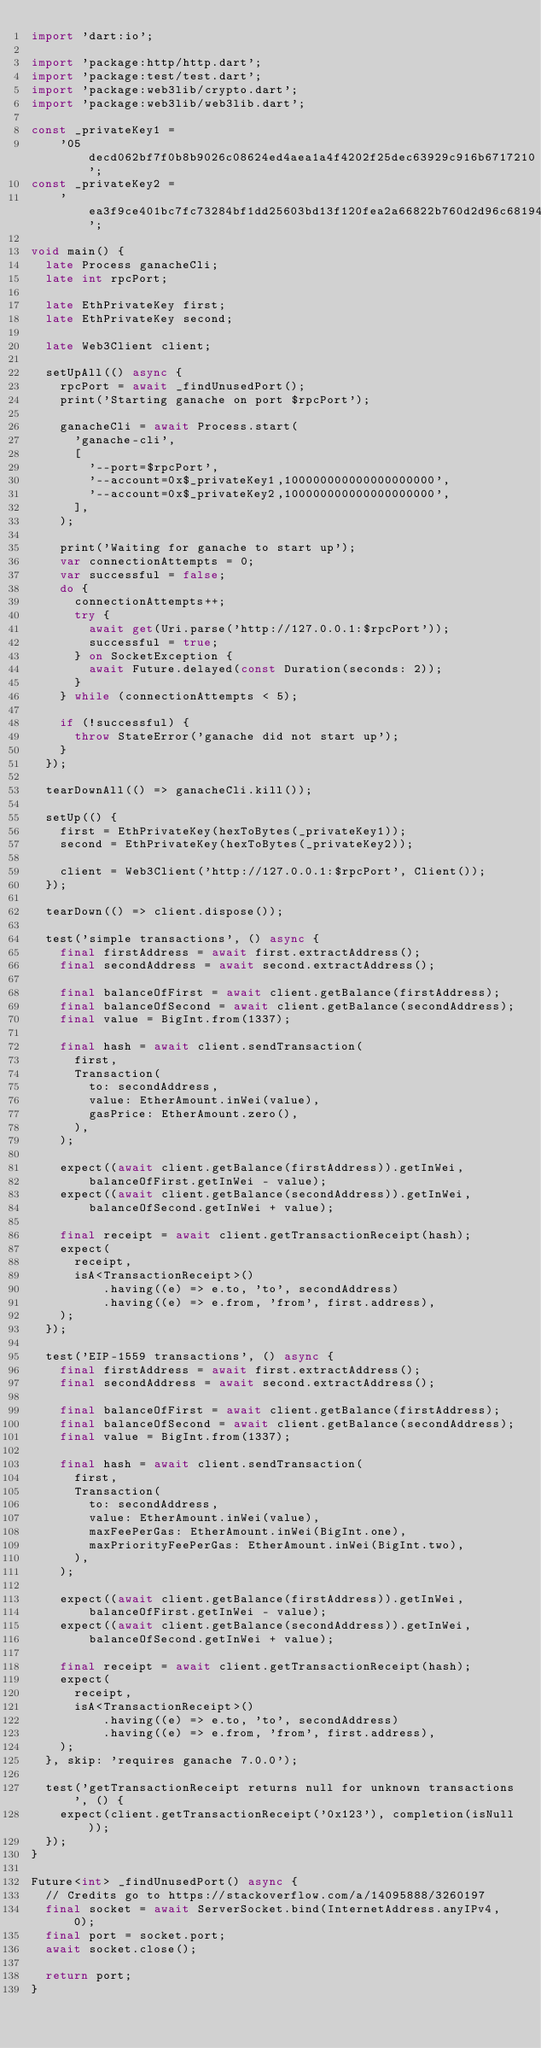<code> <loc_0><loc_0><loc_500><loc_500><_Dart_>import 'dart:io';

import 'package:http/http.dart';
import 'package:test/test.dart';
import 'package:web3lib/crypto.dart';
import 'package:web3lib/web3lib.dart';

const _privateKey1 =
    '05decd062bf7f0b8b9026c08624ed4aea1a4f4202f25dec63929c916b6717210';
const _privateKey2 =
    'ea3f9ce401bc7fc73284bf1dd25603bd13f120fea2a66822b760d2d96c68194d';

void main() {
  late Process ganacheCli;
  late int rpcPort;

  late EthPrivateKey first;
  late EthPrivateKey second;

  late Web3Client client;

  setUpAll(() async {
    rpcPort = await _findUnusedPort();
    print('Starting ganache on port $rpcPort');

    ganacheCli = await Process.start(
      'ganache-cli',
      [
        '--port=$rpcPort',
        '--account=0x$_privateKey1,100000000000000000000',
        '--account=0x$_privateKey2,100000000000000000000',
      ],
    );

    print('Waiting for ganache to start up');
    var connectionAttempts = 0;
    var successful = false;
    do {
      connectionAttempts++;
      try {
        await get(Uri.parse('http://127.0.0.1:$rpcPort'));
        successful = true;
      } on SocketException {
        await Future.delayed(const Duration(seconds: 2));
      }
    } while (connectionAttempts < 5);

    if (!successful) {
      throw StateError('ganache did not start up');
    }
  });

  tearDownAll(() => ganacheCli.kill());

  setUp(() {
    first = EthPrivateKey(hexToBytes(_privateKey1));
    second = EthPrivateKey(hexToBytes(_privateKey2));

    client = Web3Client('http://127.0.0.1:$rpcPort', Client());
  });

  tearDown(() => client.dispose());

  test('simple transactions', () async {
    final firstAddress = await first.extractAddress();
    final secondAddress = await second.extractAddress();

    final balanceOfFirst = await client.getBalance(firstAddress);
    final balanceOfSecond = await client.getBalance(secondAddress);
    final value = BigInt.from(1337);

    final hash = await client.sendTransaction(
      first,
      Transaction(
        to: secondAddress,
        value: EtherAmount.inWei(value),
        gasPrice: EtherAmount.zero(),
      ),
    );

    expect((await client.getBalance(firstAddress)).getInWei,
        balanceOfFirst.getInWei - value);
    expect((await client.getBalance(secondAddress)).getInWei,
        balanceOfSecond.getInWei + value);

    final receipt = await client.getTransactionReceipt(hash);
    expect(
      receipt,
      isA<TransactionReceipt>()
          .having((e) => e.to, 'to', secondAddress)
          .having((e) => e.from, 'from', first.address),
    );
  });

  test('EIP-1559 transactions', () async {
    final firstAddress = await first.extractAddress();
    final secondAddress = await second.extractAddress();

    final balanceOfFirst = await client.getBalance(firstAddress);
    final balanceOfSecond = await client.getBalance(secondAddress);
    final value = BigInt.from(1337);

    final hash = await client.sendTransaction(
      first,
      Transaction(
        to: secondAddress,
        value: EtherAmount.inWei(value),
        maxFeePerGas: EtherAmount.inWei(BigInt.one),
        maxPriorityFeePerGas: EtherAmount.inWei(BigInt.two),
      ),
    );

    expect((await client.getBalance(firstAddress)).getInWei,
        balanceOfFirst.getInWei - value);
    expect((await client.getBalance(secondAddress)).getInWei,
        balanceOfSecond.getInWei + value);

    final receipt = await client.getTransactionReceipt(hash);
    expect(
      receipt,
      isA<TransactionReceipt>()
          .having((e) => e.to, 'to', secondAddress)
          .having((e) => e.from, 'from', first.address),
    );
  }, skip: 'requires ganache 7.0.0');

  test('getTransactionReceipt returns null for unknown transactions', () {
    expect(client.getTransactionReceipt('0x123'), completion(isNull));
  });
}

Future<int> _findUnusedPort() async {
  // Credits go to https://stackoverflow.com/a/14095888/3260197
  final socket = await ServerSocket.bind(InternetAddress.anyIPv4, 0);
  final port = socket.port;
  await socket.close();

  return port;
}
</code> 